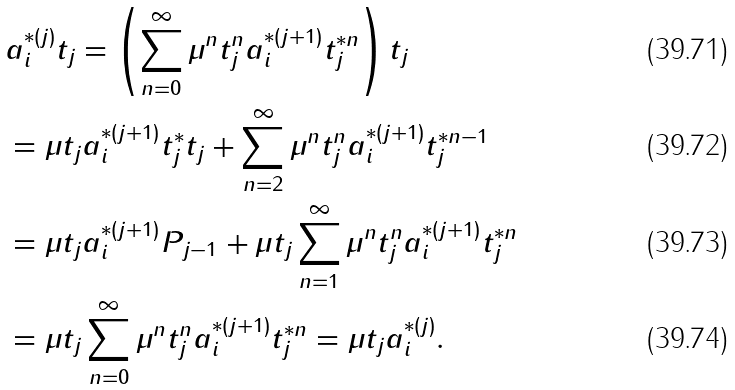Convert formula to latex. <formula><loc_0><loc_0><loc_500><loc_500>& a _ { i } ^ { * ( j ) } t _ { j } = \left ( \sum _ { n = 0 } ^ { \infty } \mu ^ { n } t _ { j } ^ { n } a _ { i } ^ { * ( j + 1 ) } t _ { j } ^ { * n } \right ) t _ { j } \\ & = \mu t _ { j } a _ { i } ^ { * ( j + 1 ) } t _ { j } ^ { * } t _ { j } + \sum _ { n = 2 } ^ { \infty } \mu ^ { n } t _ { j } ^ { n } a _ { i } ^ { * ( j + 1 ) } t _ { j } ^ { * n - 1 } \\ & = \mu t _ { j } a _ { i } ^ { * ( j + 1 ) } P _ { j - 1 } + \mu t _ { j } \sum _ { n = 1 } ^ { \infty } \mu ^ { n } t _ { j } ^ { n } a _ { i } ^ { * ( j + 1 ) } t _ { j } ^ { * n } \\ & = \mu t _ { j } \sum _ { n = 0 } ^ { \infty } \mu ^ { n } t _ { j } ^ { n } a _ { i } ^ { * ( j + 1 ) } t _ { j } ^ { * n } = \mu t _ { j } a _ { i } ^ { * ( j ) } .</formula> 